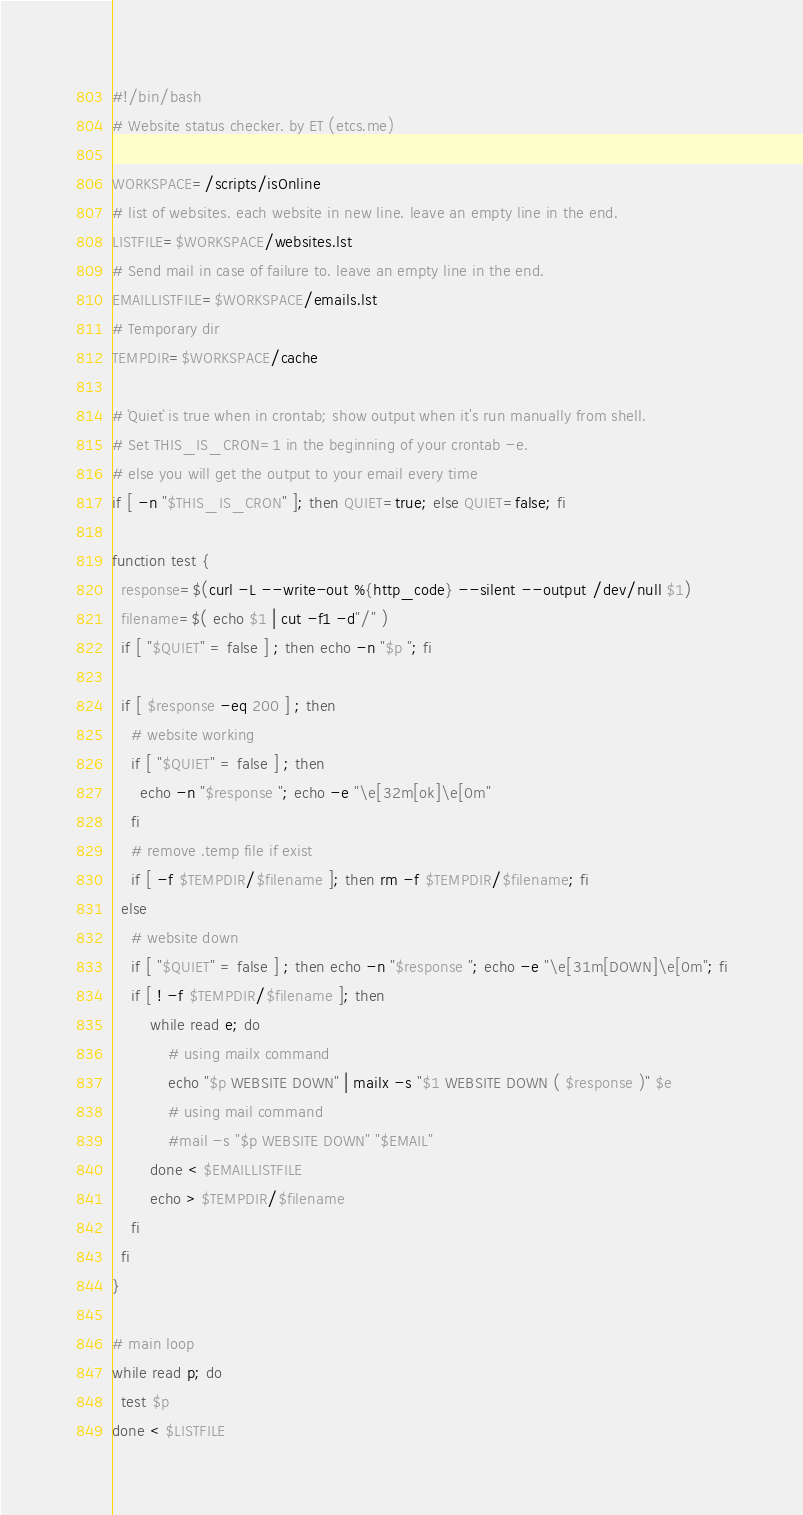Convert code to text. <code><loc_0><loc_0><loc_500><loc_500><_Bash_>#!/bin/bash
# Website status checker. by ET (etcs.me)

WORKSPACE=/scripts/isOnline
# list of websites. each website in new line. leave an empty line in the end.
LISTFILE=$WORKSPACE/websites.lst
# Send mail in case of failure to. leave an empty line in the end.
EMAILLISTFILE=$WORKSPACE/emails.lst
# Temporary dir
TEMPDIR=$WORKSPACE/cache

# `Quiet` is true when in crontab; show output when it's run manually from shell.
# Set THIS_IS_CRON=1 in the beginning of your crontab -e.
# else you will get the output to your email every time
if [ -n "$THIS_IS_CRON" ]; then QUIET=true; else QUIET=false; fi

function test {
  response=$(curl -L --write-out %{http_code} --silent --output /dev/null $1)
  filename=$( echo $1 | cut -f1 -d"/" )
  if [ "$QUIET" = false ] ; then echo -n "$p "; fi

  if [ $response -eq 200 ] ; then
    # website working
    if [ "$QUIET" = false ] ; then
      echo -n "$response "; echo -e "\e[32m[ok]\e[0m"
    fi
    # remove .temp file if exist 
    if [ -f $TEMPDIR/$filename ]; then rm -f $TEMPDIR/$filename; fi
  else
    # website down
    if [ "$QUIET" = false ] ; then echo -n "$response "; echo -e "\e[31m[DOWN]\e[0m"; fi
    if [ ! -f $TEMPDIR/$filename ]; then
        while read e; do
            # using mailx command
            echo "$p WEBSITE DOWN" | mailx -s "$1 WEBSITE DOWN ( $response )" $e
            # using mail command
            #mail -s "$p WEBSITE DOWN" "$EMAIL"
        done < $EMAILLISTFILE
        echo > $TEMPDIR/$filename
    fi
  fi
}

# main loop
while read p; do
  test $p
done < $LISTFILE
</code> 